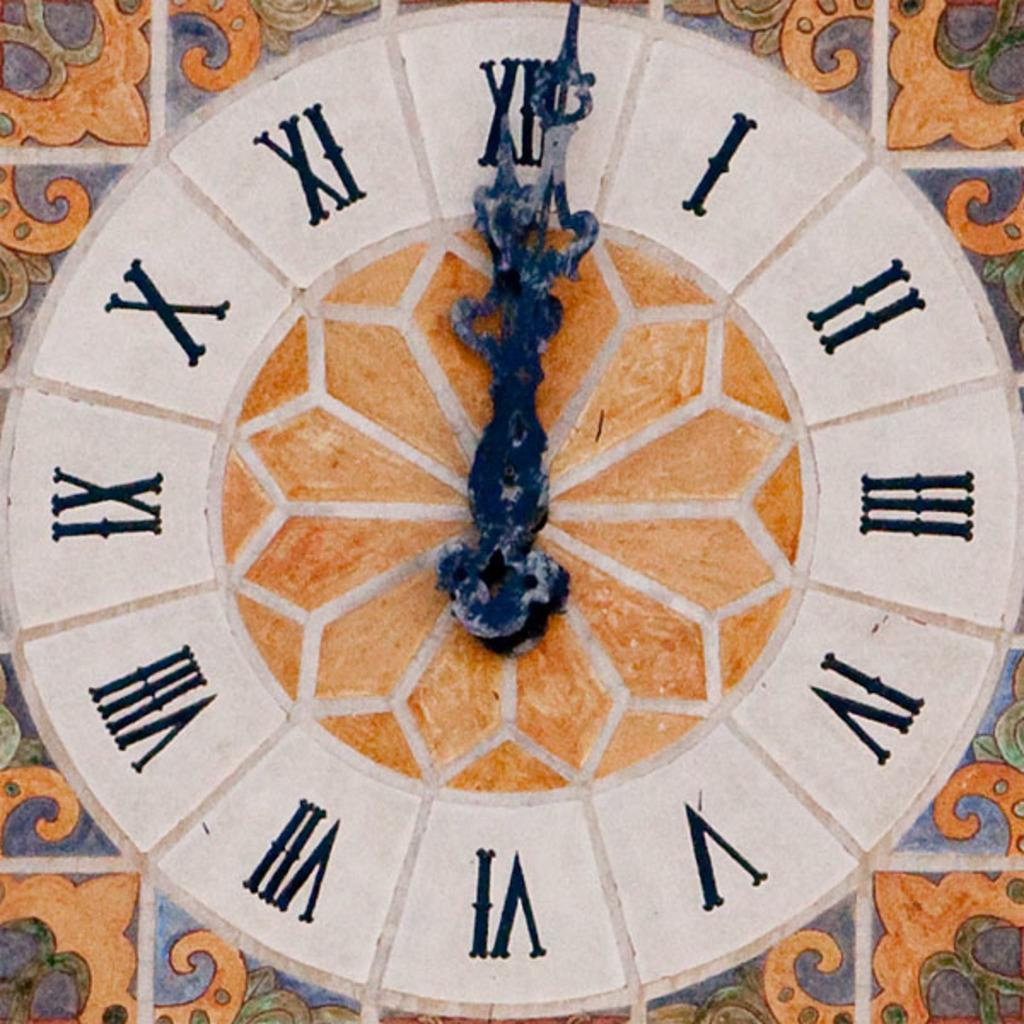What object can be seen in the image that is used for telling time? There is a clock in the image that is used for telling time. Where is the clock located in the image? The clock is attached to the wall in the image. What type of cheese is present in the image? There is no cheese present in the image. 